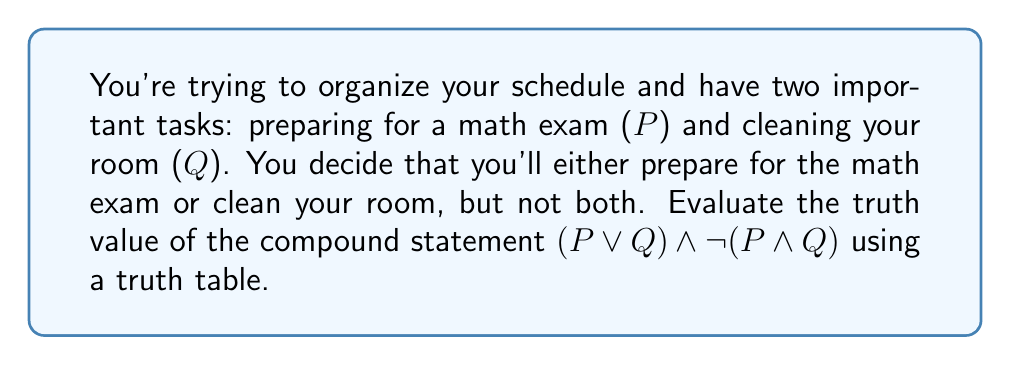What is the answer to this math problem? Let's approach this step-by-step:

1) First, we need to identify the components of our compound statement:
   - $P$: Preparing for a math exam
   - $Q$: Cleaning your room
   - The compound statement: $(P \lor Q) \land \lnot(P \land Q)$

2) Now, let's break down the compound statement:
   - $P \lor Q$: You'll do at least one of the tasks
   - $\lnot(P \land Q)$: You won't do both tasks

3) To create a truth table, we need to consider all possible combinations of P and Q:

   | P | Q | $P \lor Q$ | $P \land Q$ | $\lnot(P \land Q)$ | $(P \lor Q) \land \lnot(P \land Q)$ |
   |---|---|------------|-------------|---------------------|--------------------------------------|
   | T | T |     T      |      T      |          F          |                 F                    |
   | T | F |     T      |      F      |          T          |                 T                    |
   | F | T |     T      |      F      |          T          |                 T                    |
   | F | F |     F      |      F      |          T          |                 F                    |

4) Let's evaluate each column:
   - $P \lor Q$: True when at least one of P or Q is true
   - $P \land Q$: True only when both P and Q are true
   - $\lnot(P \land Q)$: The negation of $P \land Q$
   - $(P \lor Q) \land \lnot(P \land Q)$: True when $(P \lor Q)$ is true AND $\lnot(P \land Q)$ is true

5) The final column shows the truth value of the entire compound statement for each possible combination of P and Q.

6) We can see that the statement is true when exactly one of P or Q is true, and false otherwise.
Answer: The compound statement $(P \lor Q) \land \lnot(P \land Q)$ is true when either P is true and Q is false, or when P is false and Q is true. In other words, it's true when you do exactly one of the tasks, but not both, which aligns with your original decision. 